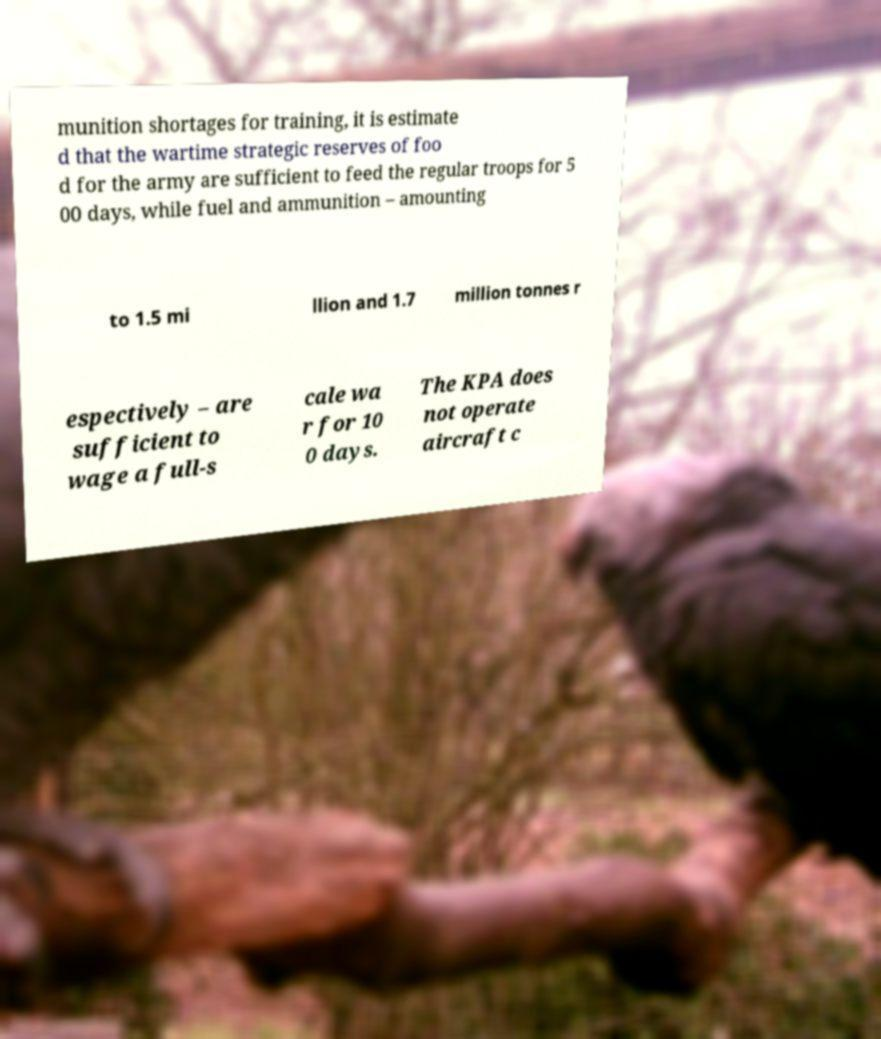Could you extract and type out the text from this image? munition shortages for training, it is estimate d that the wartime strategic reserves of foo d for the army are sufficient to feed the regular troops for 5 00 days, while fuel and ammunition – amounting to 1.5 mi llion and 1.7 million tonnes r espectively – are sufficient to wage a full-s cale wa r for 10 0 days. The KPA does not operate aircraft c 